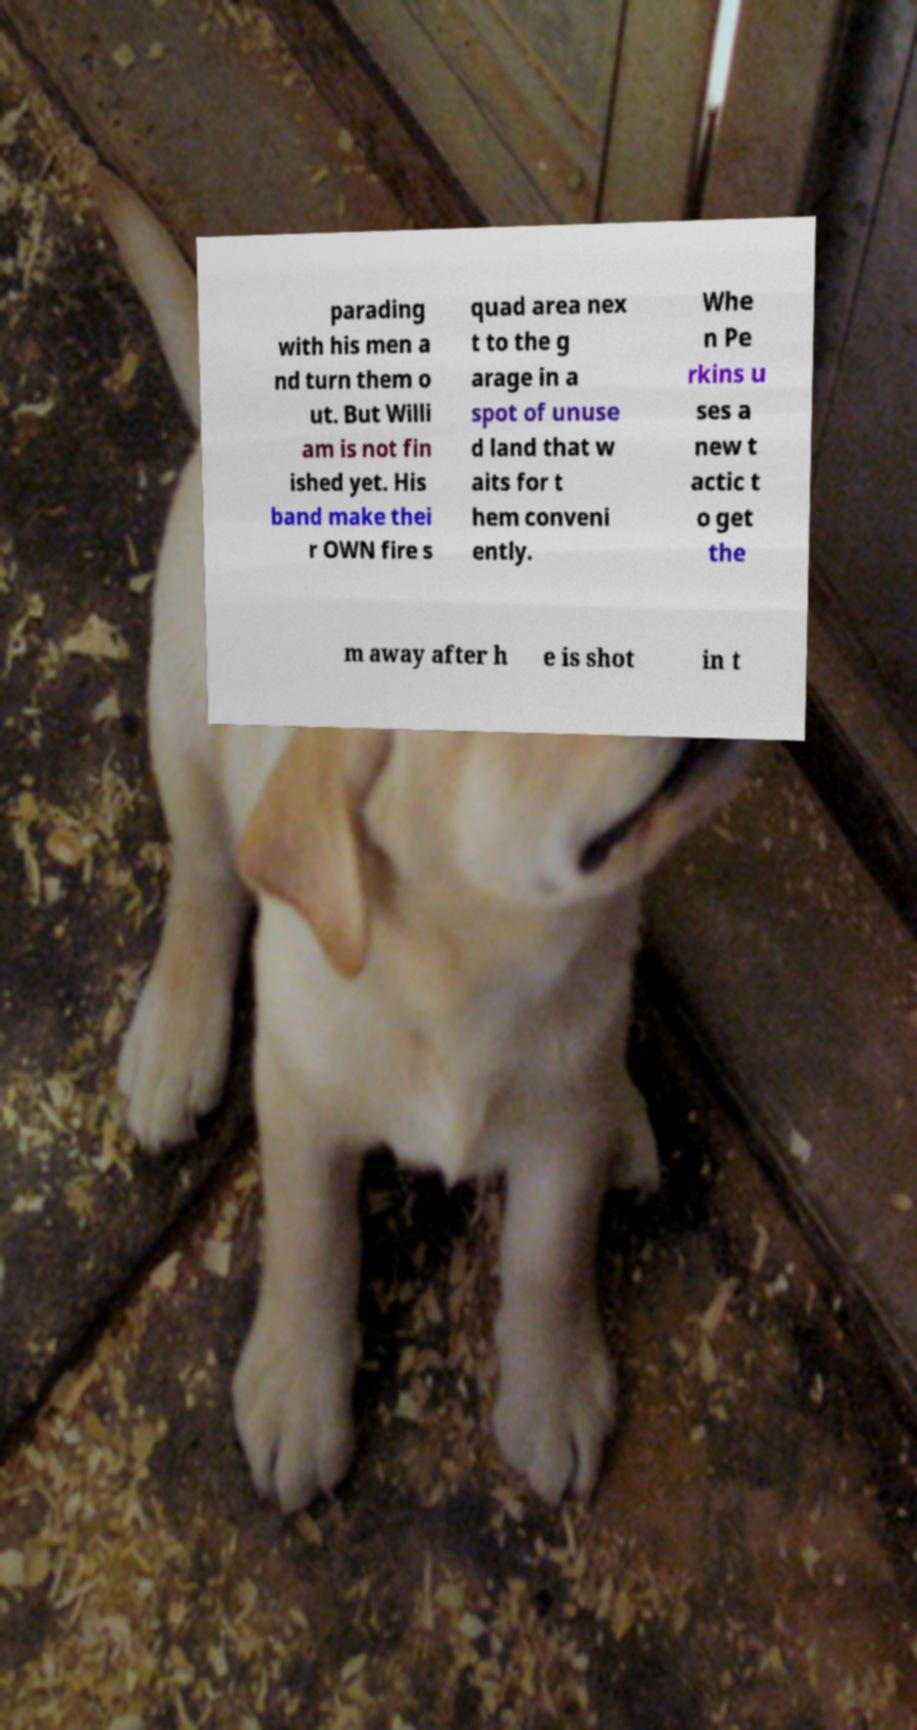I need the written content from this picture converted into text. Can you do that? parading with his men a nd turn them o ut. But Willi am is not fin ished yet. His band make thei r OWN fire s quad area nex t to the g arage in a spot of unuse d land that w aits for t hem conveni ently. Whe n Pe rkins u ses a new t actic t o get the m away after h e is shot in t 